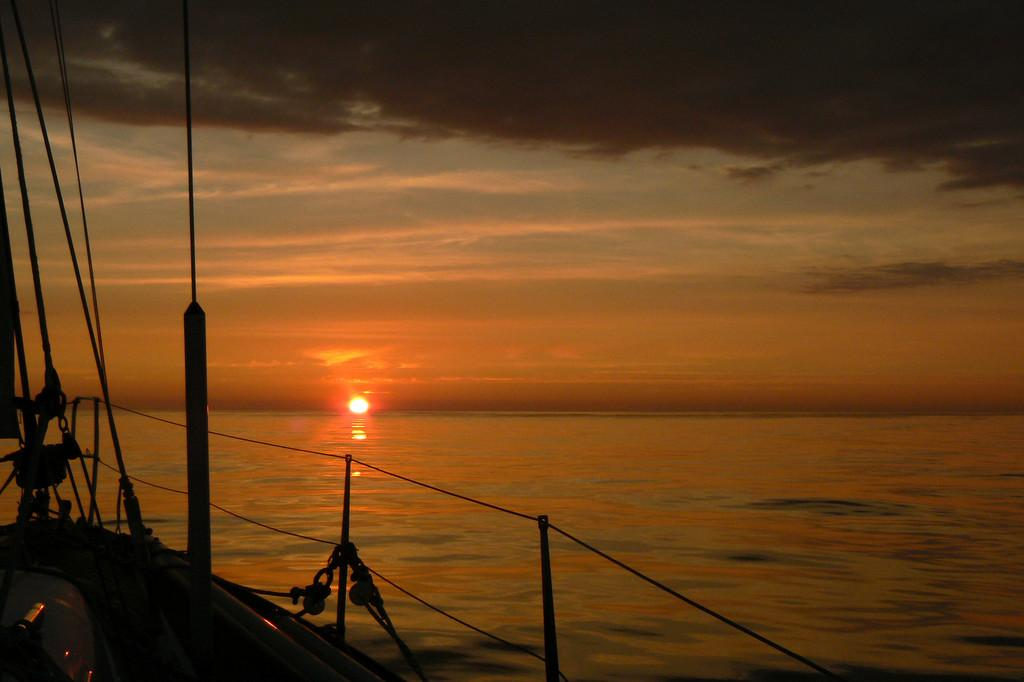What is the main subject of the image? The main subject of the image is a boat. Where is the boat located? The boat is in the water. What can be seen in the sky in the image? The sun is visible in the sky, and there are clouds present. What type of spring is visible on the boat in the image? There is no spring present on the boat in the image. How does the boat affect the father's throat in the image? There is no father or throat mentioned in the image; it only features a boat in the water with the sun and clouds visible in the sky. 